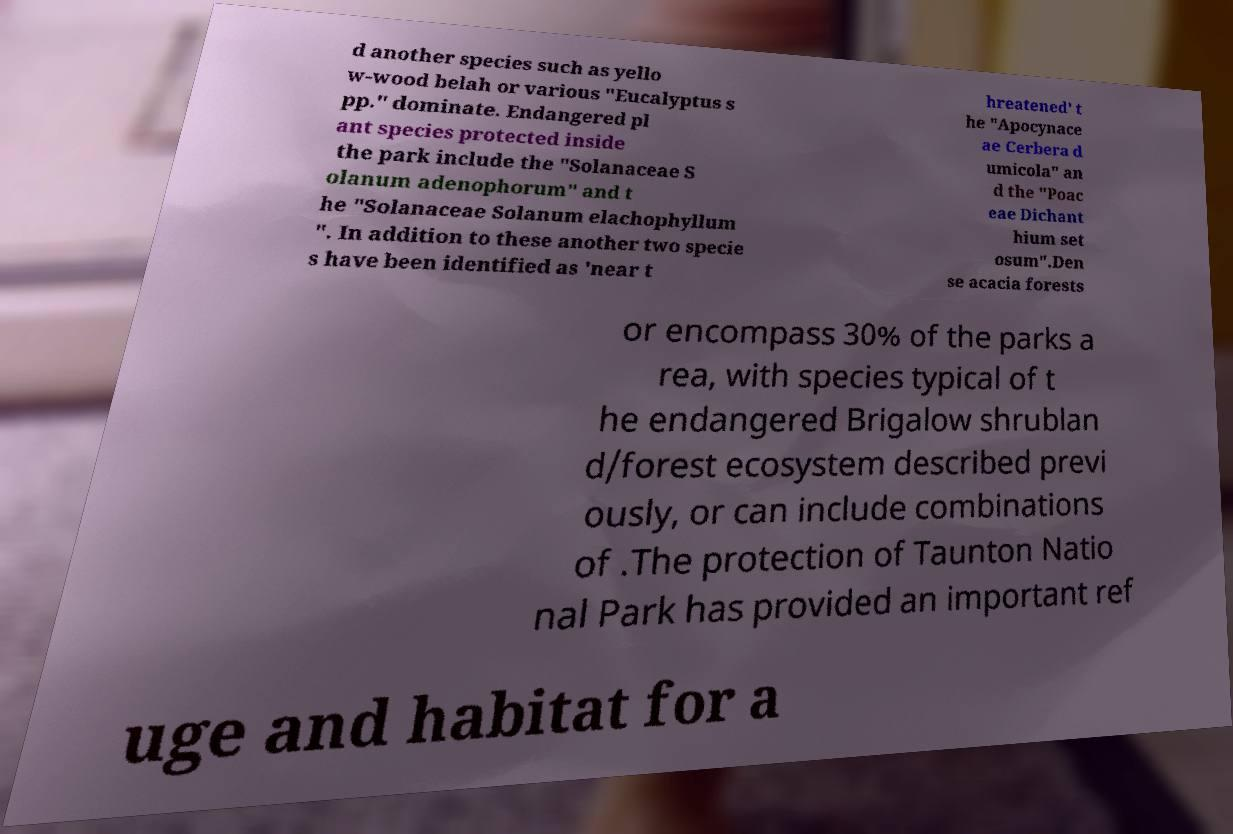What messages or text are displayed in this image? I need them in a readable, typed format. d another species such as yello w-wood belah or various "Eucalyptus s pp." dominate. Endangered pl ant species protected inside the park include the "Solanaceae S olanum adenophorum" and t he "Solanaceae Solanum elachophyllum ". In addition to these another two specie s have been identified as 'near t hreatened' t he "Apocynace ae Cerbera d umicola" an d the "Poac eae Dichant hium set osum".Den se acacia forests or encompass 30% of the parks a rea, with species typical of t he endangered Brigalow shrublan d/forest ecosystem described previ ously, or can include combinations of .The protection of Taunton Natio nal Park has provided an important ref uge and habitat for a 